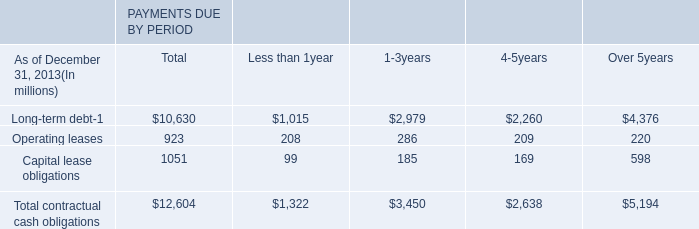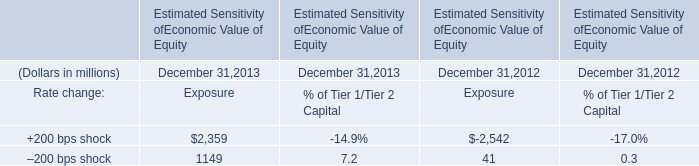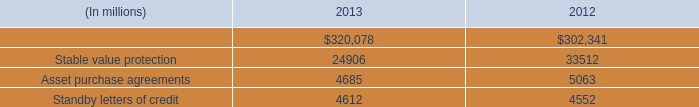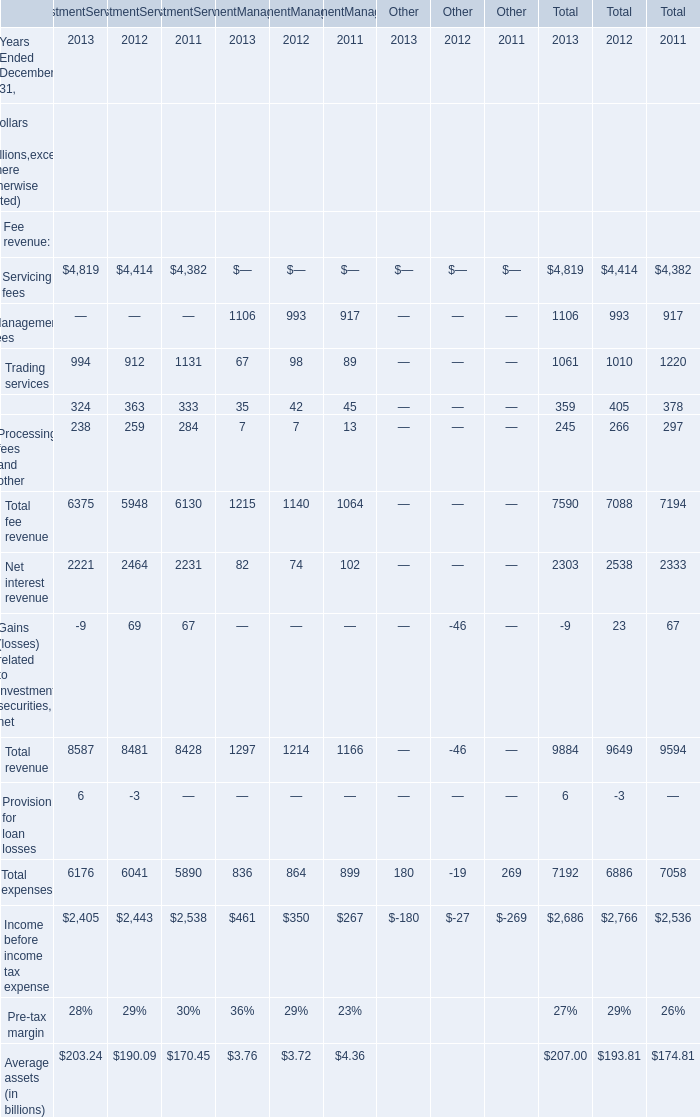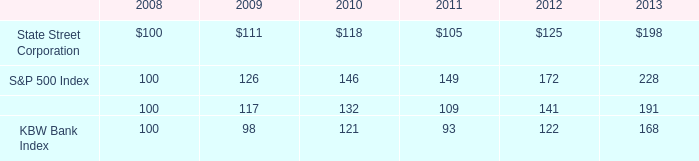what is the roi of an investment in the state street corporation from 2008 to 2011? 
Computations: ((105 - 100) / 100)
Answer: 0.05. 